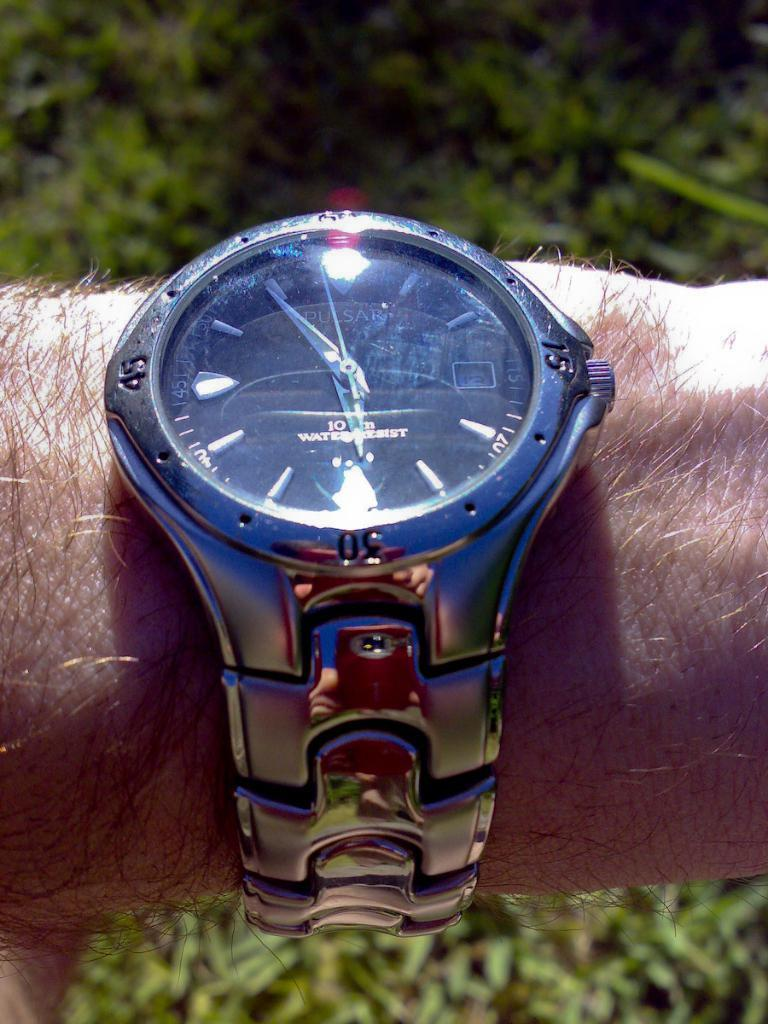<image>
Render a clear and concise summary of the photo. A person is wearing a watch on their wrist and it is 5:55. 